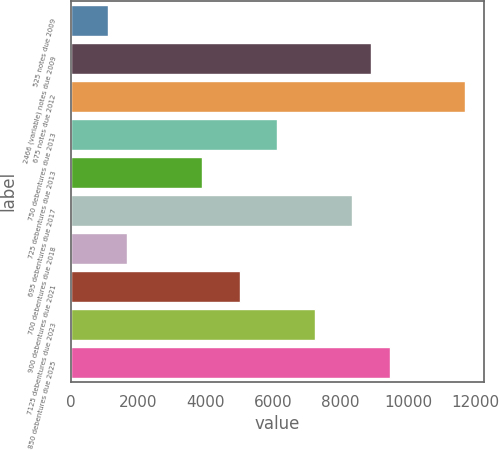<chart> <loc_0><loc_0><loc_500><loc_500><bar_chart><fcel>525 notes due 2009<fcel>2466 (variable) notes due 2009<fcel>675 notes due 2012<fcel>750 debentures due 2013<fcel>725 debentures due 2013<fcel>695 debentures due 2017<fcel>700 debentures due 2018<fcel>900 debentures due 2021<fcel>7125 debentures due 2023<fcel>850 debentures due 2025<nl><fcel>1113.6<fcel>8894.8<fcel>11673.8<fcel>6115.8<fcel>3892.6<fcel>8339<fcel>1669.4<fcel>5004.2<fcel>7227.4<fcel>9450.6<nl></chart> 